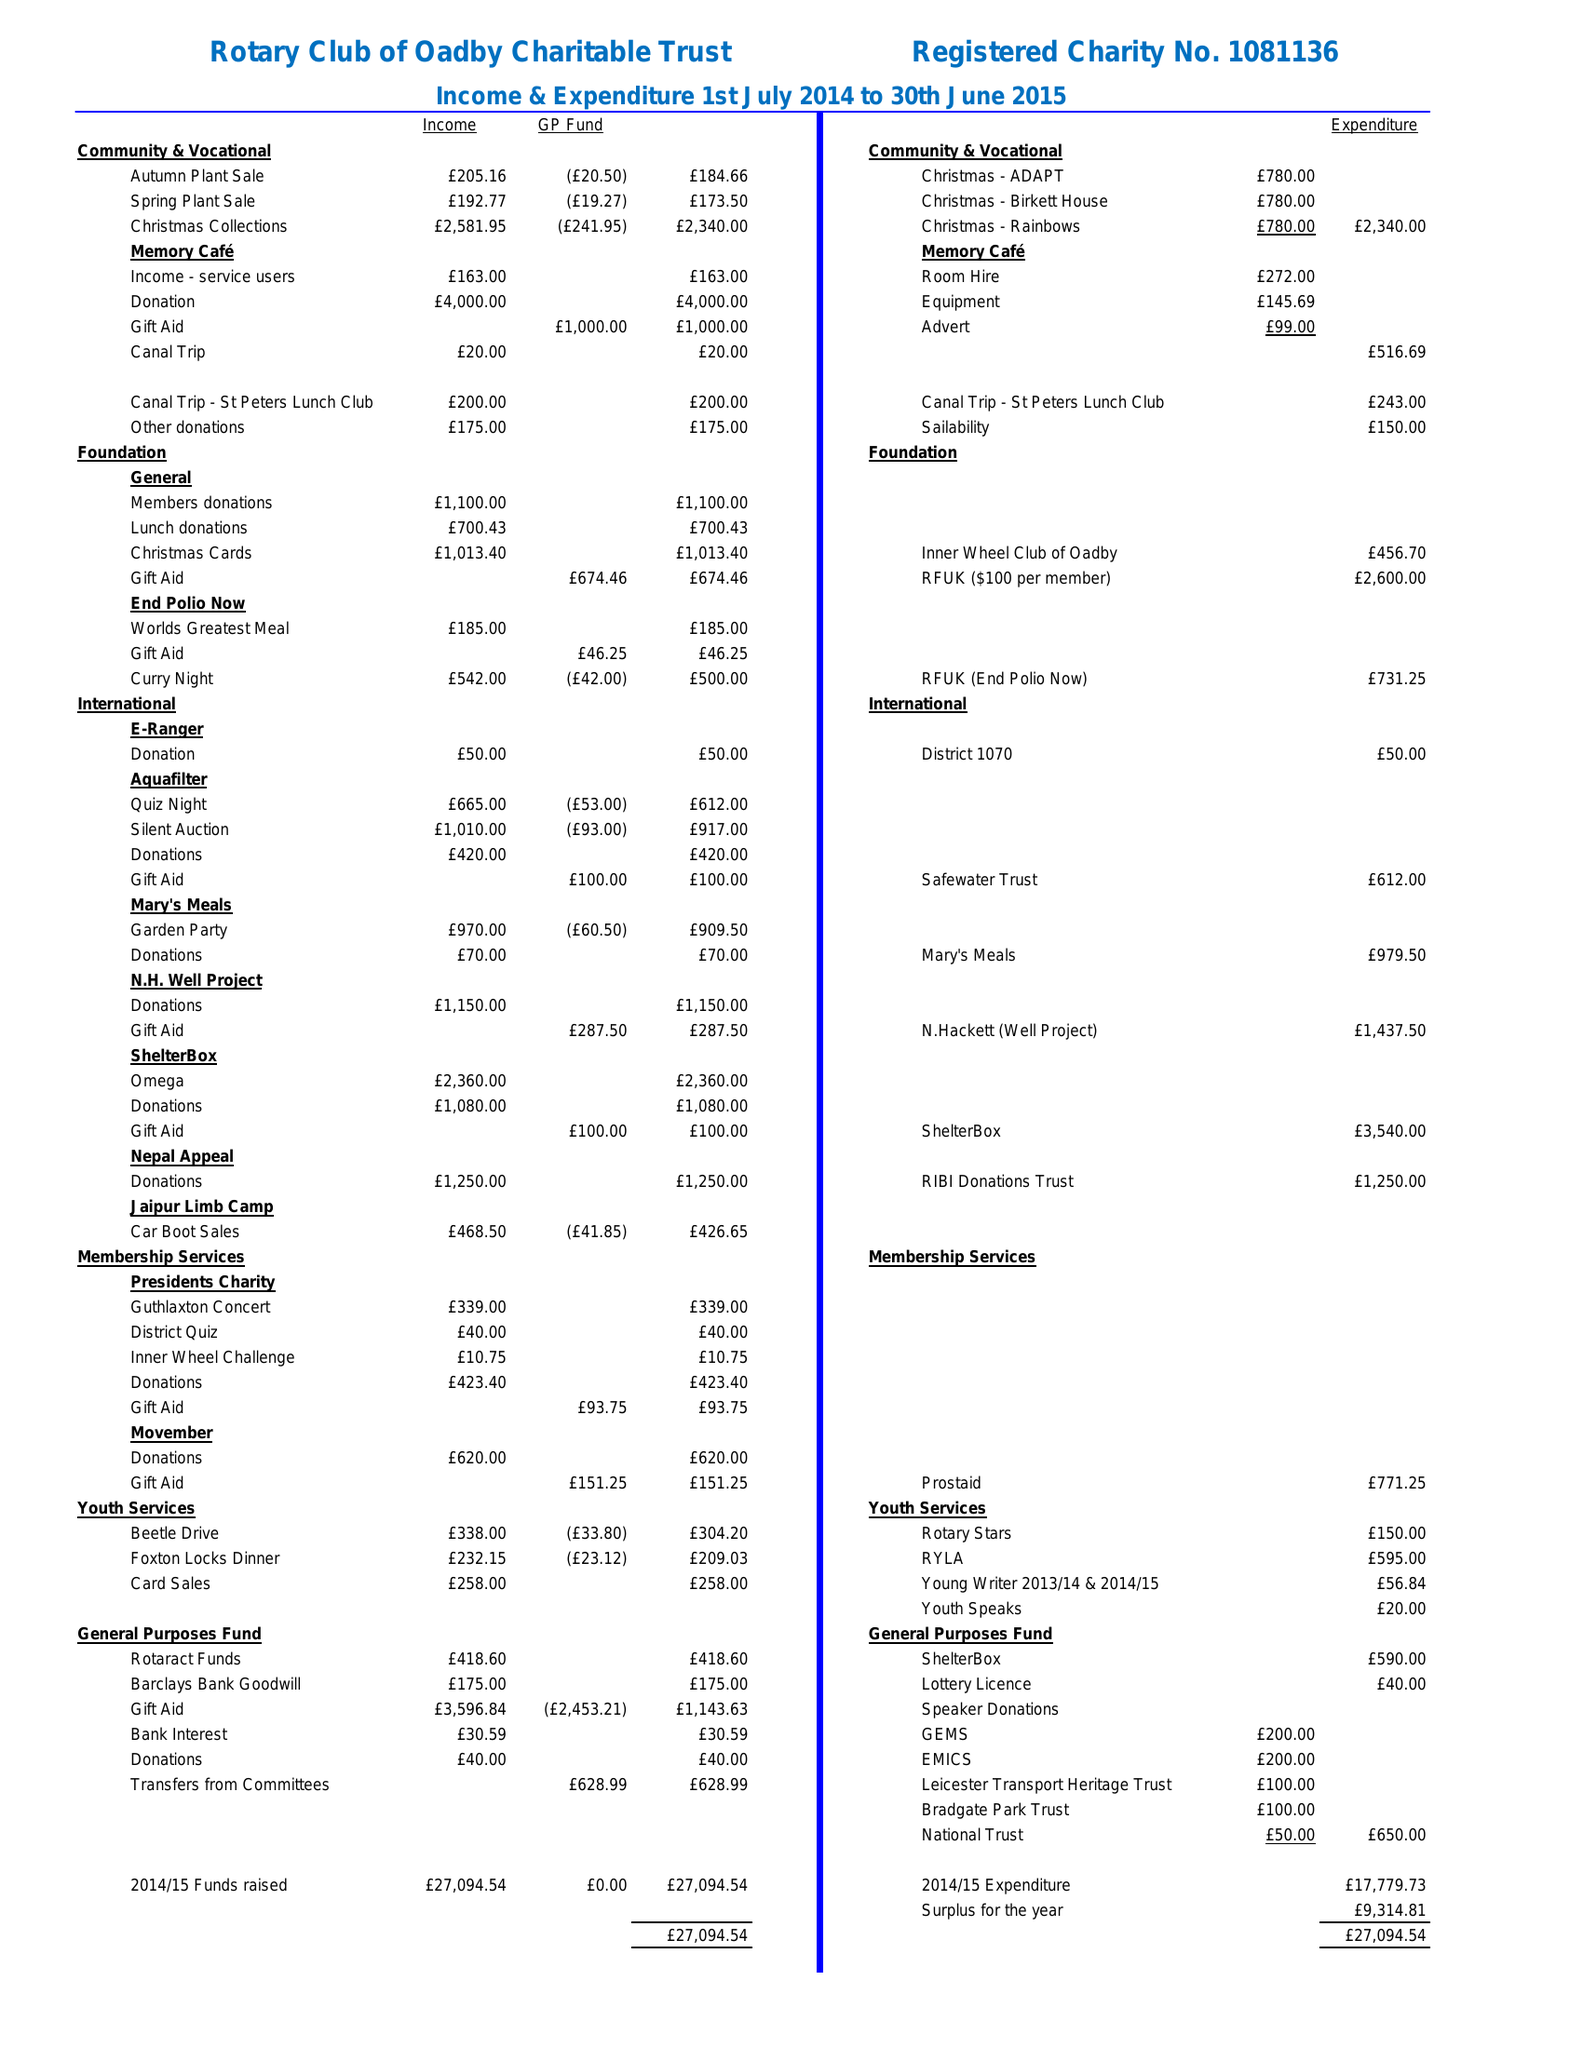What is the value for the address__postcode?
Answer the question using a single word or phrase. LE7 9RE 